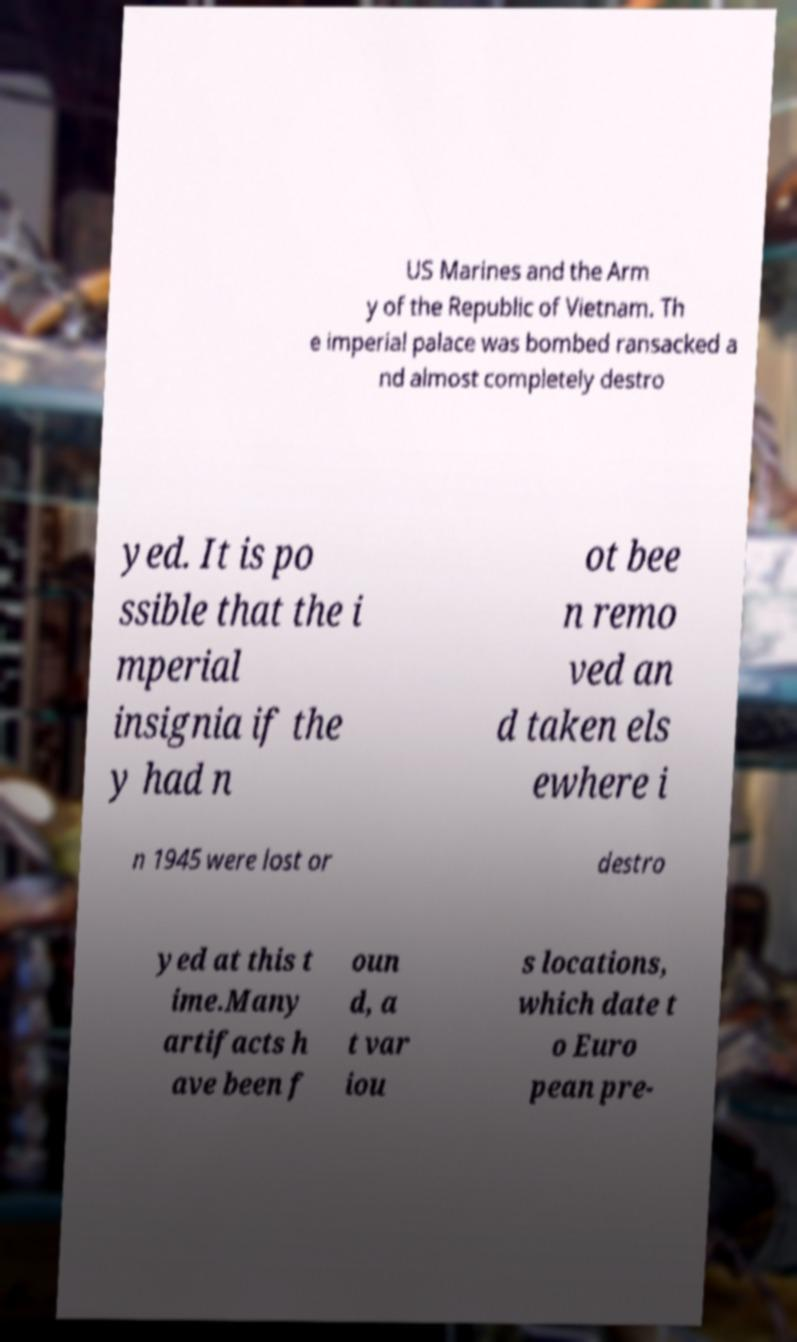Can you accurately transcribe the text from the provided image for me? US Marines and the Arm y of the Republic of Vietnam. Th e imperial palace was bombed ransacked a nd almost completely destro yed. It is po ssible that the i mperial insignia if the y had n ot bee n remo ved an d taken els ewhere i n 1945 were lost or destro yed at this t ime.Many artifacts h ave been f oun d, a t var iou s locations, which date t o Euro pean pre- 